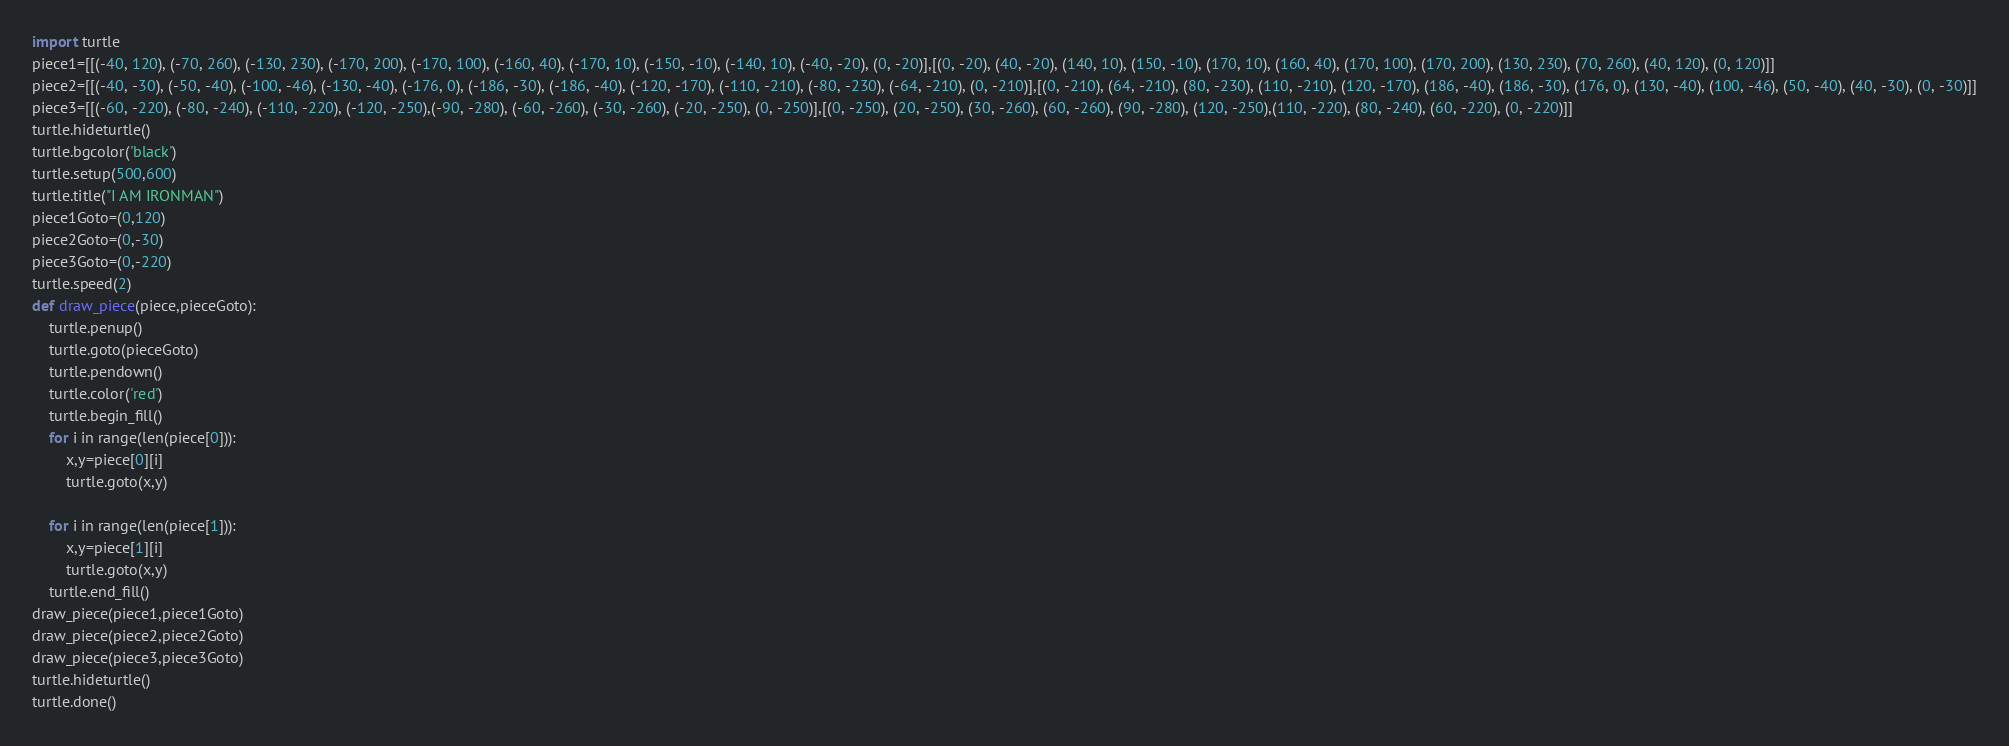Convert code to text. <code><loc_0><loc_0><loc_500><loc_500><_Python_>import turtle
piece1=[[(-40, 120), (-70, 260), (-130, 230), (-170, 200), (-170, 100), (-160, 40), (-170, 10), (-150, -10), (-140, 10), (-40, -20), (0, -20)],[(0, -20), (40, -20), (140, 10), (150, -10), (170, 10), (160, 40), (170, 100), (170, 200), (130, 230), (70, 260), (40, 120), (0, 120)]]
piece2=[[(-40, -30), (-50, -40), (-100, -46), (-130, -40), (-176, 0), (-186, -30), (-186, -40), (-120, -170), (-110, -210), (-80, -230), (-64, -210), (0, -210)],[(0, -210), (64, -210), (80, -230), (110, -210), (120, -170), (186, -40), (186, -30), (176, 0), (130, -40), (100, -46), (50, -40), (40, -30), (0, -30)]]
piece3=[[(-60, -220), (-80, -240), (-110, -220), (-120, -250),(-90, -280), (-60, -260), (-30, -260), (-20, -250), (0, -250)],[(0, -250), (20, -250), (30, -260), (60, -260), (90, -280), (120, -250),(110, -220), (80, -240), (60, -220), (0, -220)]]
turtle.hideturtle()
turtle.bgcolor('black')
turtle.setup(500,600)
turtle.title("I AM IRONMAN")
piece1Goto=(0,120)
piece2Goto=(0,-30)
piece3Goto=(0,-220)
turtle.speed(2)
def draw_piece(piece,pieceGoto):
    turtle.penup()
    turtle.goto(pieceGoto)
    turtle.pendown()
    turtle.color('red')
    turtle.begin_fill()
    for i in range(len(piece[0])):
        x,y=piece[0][i]
        turtle.goto(x,y)
    
    for i in range(len(piece[1])):
        x,y=piece[1][i]
        turtle.goto(x,y)
    turtle.end_fill()
draw_piece(piece1,piece1Goto)
draw_piece(piece2,piece2Goto)
draw_piece(piece3,piece3Goto)
turtle.hideturtle()
turtle.done()</code> 